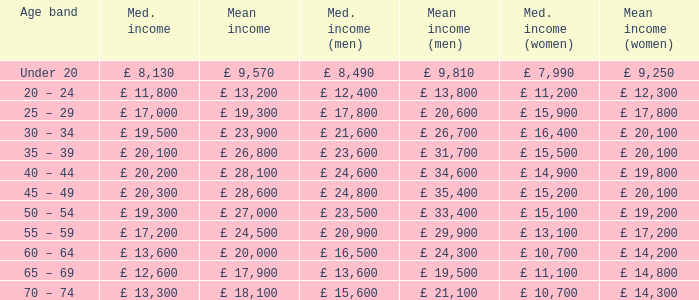Name the median income for age band being under 20 £ 8,130. 